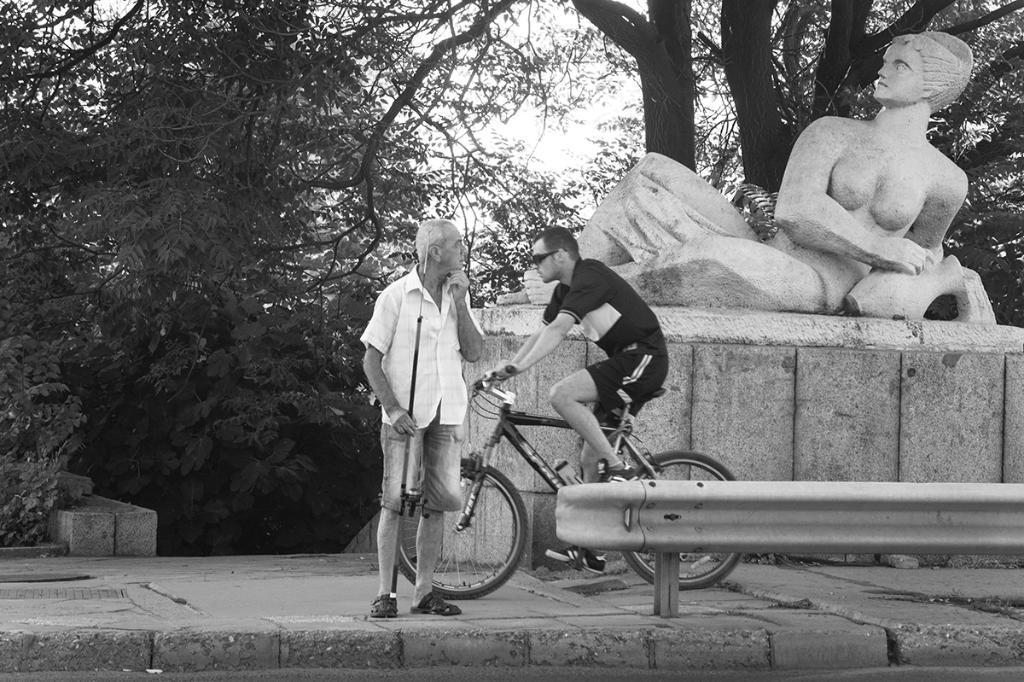What is the main subject in the image? There is a statue in the image. Are there any people present in the image? Yes, there is a man in the image. What is the other man in the image doing? The other man is riding a bicycle in the image. What country or territory is the statue representing in the image? The image does not provide any information about the country or territory the statue represents. How many letters are visible on the statue in the image? The image does not provide any information about letters on the statue. 